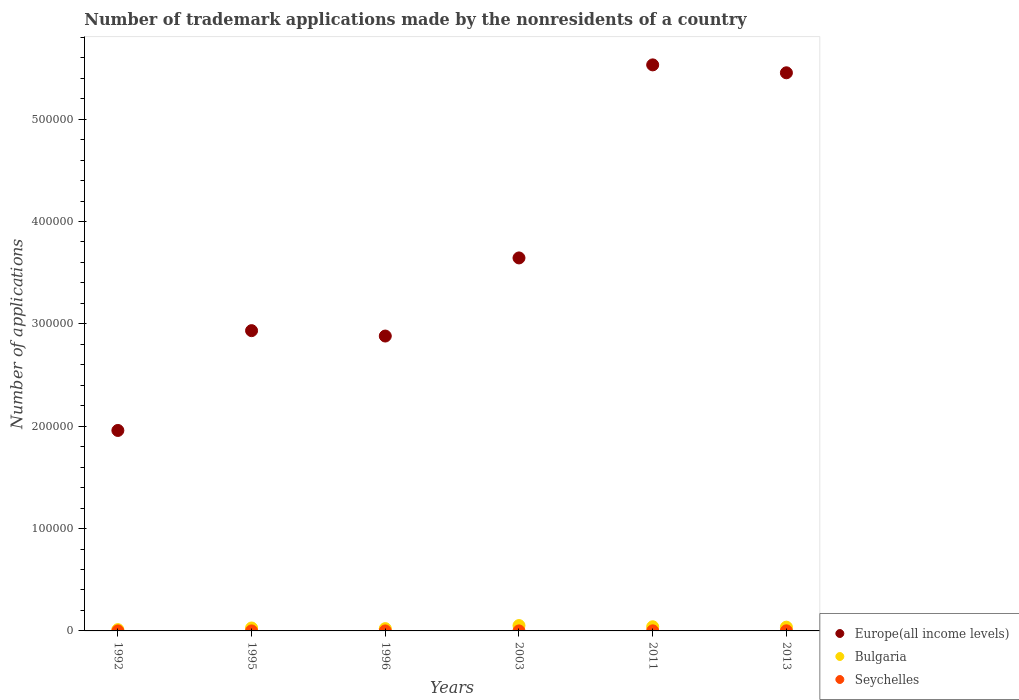How many different coloured dotlines are there?
Your answer should be compact. 3. What is the number of trademark applications made by the nonresidents in Bulgaria in 2011?
Your response must be concise. 4058. Across all years, what is the maximum number of trademark applications made by the nonresidents in Bulgaria?
Your response must be concise. 5225. Across all years, what is the minimum number of trademark applications made by the nonresidents in Europe(all income levels)?
Your response must be concise. 1.96e+05. In which year was the number of trademark applications made by the nonresidents in Europe(all income levels) minimum?
Provide a succinct answer. 1992. What is the total number of trademark applications made by the nonresidents in Seychelles in the graph?
Give a very brief answer. 244. What is the difference between the number of trademark applications made by the nonresidents in Bulgaria in 2011 and that in 2013?
Your answer should be very brief. 378. What is the difference between the number of trademark applications made by the nonresidents in Bulgaria in 2013 and the number of trademark applications made by the nonresidents in Seychelles in 1995?
Your response must be concise. 3664. What is the average number of trademark applications made by the nonresidents in Seychelles per year?
Offer a very short reply. 40.67. In the year 1995, what is the difference between the number of trademark applications made by the nonresidents in Bulgaria and number of trademark applications made by the nonresidents in Seychelles?
Your answer should be compact. 2843. In how many years, is the number of trademark applications made by the nonresidents in Europe(all income levels) greater than 60000?
Make the answer very short. 6. What is the ratio of the number of trademark applications made by the nonresidents in Bulgaria in 1992 to that in 2013?
Keep it short and to the point. 0.34. What is the difference between the highest and the lowest number of trademark applications made by the nonresidents in Bulgaria?
Offer a very short reply. 3973. Is it the case that in every year, the sum of the number of trademark applications made by the nonresidents in Seychelles and number of trademark applications made by the nonresidents in Europe(all income levels)  is greater than the number of trademark applications made by the nonresidents in Bulgaria?
Offer a terse response. Yes. Does the number of trademark applications made by the nonresidents in Bulgaria monotonically increase over the years?
Keep it short and to the point. No. Is the number of trademark applications made by the nonresidents in Seychelles strictly greater than the number of trademark applications made by the nonresidents in Bulgaria over the years?
Give a very brief answer. No. Is the number of trademark applications made by the nonresidents in Bulgaria strictly less than the number of trademark applications made by the nonresidents in Seychelles over the years?
Your answer should be very brief. No. How many dotlines are there?
Give a very brief answer. 3. Does the graph contain grids?
Provide a short and direct response. No. Where does the legend appear in the graph?
Your answer should be compact. Bottom right. What is the title of the graph?
Your answer should be very brief. Number of trademark applications made by the nonresidents of a country. Does "Least developed countries" appear as one of the legend labels in the graph?
Your response must be concise. No. What is the label or title of the X-axis?
Make the answer very short. Years. What is the label or title of the Y-axis?
Give a very brief answer. Number of applications. What is the Number of applications of Europe(all income levels) in 1992?
Provide a short and direct response. 1.96e+05. What is the Number of applications in Bulgaria in 1992?
Offer a very short reply. 1252. What is the Number of applications of Seychelles in 1992?
Give a very brief answer. 3. What is the Number of applications in Europe(all income levels) in 1995?
Your answer should be compact. 2.93e+05. What is the Number of applications in Bulgaria in 1995?
Your answer should be very brief. 2859. What is the Number of applications in Seychelles in 1995?
Make the answer very short. 16. What is the Number of applications in Europe(all income levels) in 1996?
Your response must be concise. 2.88e+05. What is the Number of applications in Bulgaria in 1996?
Your response must be concise. 2243. What is the Number of applications of Seychelles in 1996?
Your answer should be compact. 12. What is the Number of applications of Europe(all income levels) in 2003?
Offer a very short reply. 3.64e+05. What is the Number of applications of Bulgaria in 2003?
Offer a terse response. 5225. What is the Number of applications in Europe(all income levels) in 2011?
Offer a very short reply. 5.53e+05. What is the Number of applications of Bulgaria in 2011?
Provide a succinct answer. 4058. What is the Number of applications of Seychelles in 2011?
Provide a short and direct response. 91. What is the Number of applications in Europe(all income levels) in 2013?
Give a very brief answer. 5.45e+05. What is the Number of applications of Bulgaria in 2013?
Provide a succinct answer. 3680. What is the Number of applications in Seychelles in 2013?
Ensure brevity in your answer.  106. Across all years, what is the maximum Number of applications of Europe(all income levels)?
Offer a very short reply. 5.53e+05. Across all years, what is the maximum Number of applications in Bulgaria?
Your answer should be compact. 5225. Across all years, what is the maximum Number of applications of Seychelles?
Give a very brief answer. 106. Across all years, what is the minimum Number of applications in Europe(all income levels)?
Give a very brief answer. 1.96e+05. Across all years, what is the minimum Number of applications in Bulgaria?
Keep it short and to the point. 1252. What is the total Number of applications in Europe(all income levels) in the graph?
Offer a very short reply. 2.24e+06. What is the total Number of applications of Bulgaria in the graph?
Provide a succinct answer. 1.93e+04. What is the total Number of applications of Seychelles in the graph?
Provide a succinct answer. 244. What is the difference between the Number of applications in Europe(all income levels) in 1992 and that in 1995?
Provide a short and direct response. -9.75e+04. What is the difference between the Number of applications of Bulgaria in 1992 and that in 1995?
Your answer should be compact. -1607. What is the difference between the Number of applications of Seychelles in 1992 and that in 1995?
Provide a succinct answer. -13. What is the difference between the Number of applications of Europe(all income levels) in 1992 and that in 1996?
Make the answer very short. -9.22e+04. What is the difference between the Number of applications of Bulgaria in 1992 and that in 1996?
Your answer should be very brief. -991. What is the difference between the Number of applications in Europe(all income levels) in 1992 and that in 2003?
Give a very brief answer. -1.69e+05. What is the difference between the Number of applications in Bulgaria in 1992 and that in 2003?
Give a very brief answer. -3973. What is the difference between the Number of applications in Seychelles in 1992 and that in 2003?
Offer a very short reply. -13. What is the difference between the Number of applications of Europe(all income levels) in 1992 and that in 2011?
Give a very brief answer. -3.57e+05. What is the difference between the Number of applications of Bulgaria in 1992 and that in 2011?
Make the answer very short. -2806. What is the difference between the Number of applications in Seychelles in 1992 and that in 2011?
Provide a short and direct response. -88. What is the difference between the Number of applications of Europe(all income levels) in 1992 and that in 2013?
Provide a succinct answer. -3.49e+05. What is the difference between the Number of applications in Bulgaria in 1992 and that in 2013?
Provide a succinct answer. -2428. What is the difference between the Number of applications in Seychelles in 1992 and that in 2013?
Make the answer very short. -103. What is the difference between the Number of applications in Europe(all income levels) in 1995 and that in 1996?
Make the answer very short. 5266. What is the difference between the Number of applications of Bulgaria in 1995 and that in 1996?
Your response must be concise. 616. What is the difference between the Number of applications of Europe(all income levels) in 1995 and that in 2003?
Give a very brief answer. -7.10e+04. What is the difference between the Number of applications in Bulgaria in 1995 and that in 2003?
Ensure brevity in your answer.  -2366. What is the difference between the Number of applications in Seychelles in 1995 and that in 2003?
Give a very brief answer. 0. What is the difference between the Number of applications in Europe(all income levels) in 1995 and that in 2011?
Provide a succinct answer. -2.60e+05. What is the difference between the Number of applications of Bulgaria in 1995 and that in 2011?
Give a very brief answer. -1199. What is the difference between the Number of applications of Seychelles in 1995 and that in 2011?
Give a very brief answer. -75. What is the difference between the Number of applications in Europe(all income levels) in 1995 and that in 2013?
Give a very brief answer. -2.52e+05. What is the difference between the Number of applications in Bulgaria in 1995 and that in 2013?
Give a very brief answer. -821. What is the difference between the Number of applications in Seychelles in 1995 and that in 2013?
Your answer should be very brief. -90. What is the difference between the Number of applications of Europe(all income levels) in 1996 and that in 2003?
Ensure brevity in your answer.  -7.63e+04. What is the difference between the Number of applications of Bulgaria in 1996 and that in 2003?
Offer a terse response. -2982. What is the difference between the Number of applications in Europe(all income levels) in 1996 and that in 2011?
Your response must be concise. -2.65e+05. What is the difference between the Number of applications of Bulgaria in 1996 and that in 2011?
Offer a very short reply. -1815. What is the difference between the Number of applications in Seychelles in 1996 and that in 2011?
Your answer should be compact. -79. What is the difference between the Number of applications of Europe(all income levels) in 1996 and that in 2013?
Ensure brevity in your answer.  -2.57e+05. What is the difference between the Number of applications in Bulgaria in 1996 and that in 2013?
Keep it short and to the point. -1437. What is the difference between the Number of applications of Seychelles in 1996 and that in 2013?
Keep it short and to the point. -94. What is the difference between the Number of applications in Europe(all income levels) in 2003 and that in 2011?
Give a very brief answer. -1.89e+05. What is the difference between the Number of applications in Bulgaria in 2003 and that in 2011?
Offer a terse response. 1167. What is the difference between the Number of applications of Seychelles in 2003 and that in 2011?
Ensure brevity in your answer.  -75. What is the difference between the Number of applications in Europe(all income levels) in 2003 and that in 2013?
Your answer should be compact. -1.81e+05. What is the difference between the Number of applications in Bulgaria in 2003 and that in 2013?
Give a very brief answer. 1545. What is the difference between the Number of applications in Seychelles in 2003 and that in 2013?
Your answer should be compact. -90. What is the difference between the Number of applications in Europe(all income levels) in 2011 and that in 2013?
Provide a short and direct response. 7737. What is the difference between the Number of applications of Bulgaria in 2011 and that in 2013?
Offer a terse response. 378. What is the difference between the Number of applications of Seychelles in 2011 and that in 2013?
Give a very brief answer. -15. What is the difference between the Number of applications of Europe(all income levels) in 1992 and the Number of applications of Bulgaria in 1995?
Your answer should be compact. 1.93e+05. What is the difference between the Number of applications in Europe(all income levels) in 1992 and the Number of applications in Seychelles in 1995?
Offer a very short reply. 1.96e+05. What is the difference between the Number of applications in Bulgaria in 1992 and the Number of applications in Seychelles in 1995?
Offer a very short reply. 1236. What is the difference between the Number of applications of Europe(all income levels) in 1992 and the Number of applications of Bulgaria in 1996?
Your response must be concise. 1.94e+05. What is the difference between the Number of applications of Europe(all income levels) in 1992 and the Number of applications of Seychelles in 1996?
Provide a short and direct response. 1.96e+05. What is the difference between the Number of applications of Bulgaria in 1992 and the Number of applications of Seychelles in 1996?
Provide a succinct answer. 1240. What is the difference between the Number of applications in Europe(all income levels) in 1992 and the Number of applications in Bulgaria in 2003?
Your answer should be very brief. 1.91e+05. What is the difference between the Number of applications of Europe(all income levels) in 1992 and the Number of applications of Seychelles in 2003?
Your response must be concise. 1.96e+05. What is the difference between the Number of applications of Bulgaria in 1992 and the Number of applications of Seychelles in 2003?
Offer a terse response. 1236. What is the difference between the Number of applications in Europe(all income levels) in 1992 and the Number of applications in Bulgaria in 2011?
Offer a terse response. 1.92e+05. What is the difference between the Number of applications of Europe(all income levels) in 1992 and the Number of applications of Seychelles in 2011?
Give a very brief answer. 1.96e+05. What is the difference between the Number of applications of Bulgaria in 1992 and the Number of applications of Seychelles in 2011?
Your answer should be compact. 1161. What is the difference between the Number of applications of Europe(all income levels) in 1992 and the Number of applications of Bulgaria in 2013?
Offer a terse response. 1.92e+05. What is the difference between the Number of applications in Europe(all income levels) in 1992 and the Number of applications in Seychelles in 2013?
Keep it short and to the point. 1.96e+05. What is the difference between the Number of applications of Bulgaria in 1992 and the Number of applications of Seychelles in 2013?
Offer a very short reply. 1146. What is the difference between the Number of applications of Europe(all income levels) in 1995 and the Number of applications of Bulgaria in 1996?
Provide a succinct answer. 2.91e+05. What is the difference between the Number of applications of Europe(all income levels) in 1995 and the Number of applications of Seychelles in 1996?
Your answer should be very brief. 2.93e+05. What is the difference between the Number of applications in Bulgaria in 1995 and the Number of applications in Seychelles in 1996?
Provide a succinct answer. 2847. What is the difference between the Number of applications of Europe(all income levels) in 1995 and the Number of applications of Bulgaria in 2003?
Make the answer very short. 2.88e+05. What is the difference between the Number of applications of Europe(all income levels) in 1995 and the Number of applications of Seychelles in 2003?
Ensure brevity in your answer.  2.93e+05. What is the difference between the Number of applications of Bulgaria in 1995 and the Number of applications of Seychelles in 2003?
Your answer should be compact. 2843. What is the difference between the Number of applications of Europe(all income levels) in 1995 and the Number of applications of Bulgaria in 2011?
Your answer should be compact. 2.89e+05. What is the difference between the Number of applications in Europe(all income levels) in 1995 and the Number of applications in Seychelles in 2011?
Provide a short and direct response. 2.93e+05. What is the difference between the Number of applications in Bulgaria in 1995 and the Number of applications in Seychelles in 2011?
Provide a short and direct response. 2768. What is the difference between the Number of applications of Europe(all income levels) in 1995 and the Number of applications of Bulgaria in 2013?
Your answer should be very brief. 2.90e+05. What is the difference between the Number of applications in Europe(all income levels) in 1995 and the Number of applications in Seychelles in 2013?
Keep it short and to the point. 2.93e+05. What is the difference between the Number of applications of Bulgaria in 1995 and the Number of applications of Seychelles in 2013?
Ensure brevity in your answer.  2753. What is the difference between the Number of applications of Europe(all income levels) in 1996 and the Number of applications of Bulgaria in 2003?
Offer a very short reply. 2.83e+05. What is the difference between the Number of applications in Europe(all income levels) in 1996 and the Number of applications in Seychelles in 2003?
Your response must be concise. 2.88e+05. What is the difference between the Number of applications of Bulgaria in 1996 and the Number of applications of Seychelles in 2003?
Offer a terse response. 2227. What is the difference between the Number of applications of Europe(all income levels) in 1996 and the Number of applications of Bulgaria in 2011?
Make the answer very short. 2.84e+05. What is the difference between the Number of applications of Europe(all income levels) in 1996 and the Number of applications of Seychelles in 2011?
Offer a terse response. 2.88e+05. What is the difference between the Number of applications in Bulgaria in 1996 and the Number of applications in Seychelles in 2011?
Ensure brevity in your answer.  2152. What is the difference between the Number of applications in Europe(all income levels) in 1996 and the Number of applications in Bulgaria in 2013?
Your answer should be compact. 2.84e+05. What is the difference between the Number of applications of Europe(all income levels) in 1996 and the Number of applications of Seychelles in 2013?
Give a very brief answer. 2.88e+05. What is the difference between the Number of applications in Bulgaria in 1996 and the Number of applications in Seychelles in 2013?
Your answer should be very brief. 2137. What is the difference between the Number of applications of Europe(all income levels) in 2003 and the Number of applications of Bulgaria in 2011?
Your response must be concise. 3.60e+05. What is the difference between the Number of applications of Europe(all income levels) in 2003 and the Number of applications of Seychelles in 2011?
Make the answer very short. 3.64e+05. What is the difference between the Number of applications in Bulgaria in 2003 and the Number of applications in Seychelles in 2011?
Give a very brief answer. 5134. What is the difference between the Number of applications in Europe(all income levels) in 2003 and the Number of applications in Bulgaria in 2013?
Provide a short and direct response. 3.61e+05. What is the difference between the Number of applications in Europe(all income levels) in 2003 and the Number of applications in Seychelles in 2013?
Offer a terse response. 3.64e+05. What is the difference between the Number of applications in Bulgaria in 2003 and the Number of applications in Seychelles in 2013?
Give a very brief answer. 5119. What is the difference between the Number of applications of Europe(all income levels) in 2011 and the Number of applications of Bulgaria in 2013?
Your answer should be very brief. 5.49e+05. What is the difference between the Number of applications of Europe(all income levels) in 2011 and the Number of applications of Seychelles in 2013?
Offer a very short reply. 5.53e+05. What is the difference between the Number of applications of Bulgaria in 2011 and the Number of applications of Seychelles in 2013?
Provide a succinct answer. 3952. What is the average Number of applications of Europe(all income levels) per year?
Provide a short and direct response. 3.73e+05. What is the average Number of applications in Bulgaria per year?
Your answer should be very brief. 3219.5. What is the average Number of applications in Seychelles per year?
Your answer should be very brief. 40.67. In the year 1992, what is the difference between the Number of applications in Europe(all income levels) and Number of applications in Bulgaria?
Ensure brevity in your answer.  1.95e+05. In the year 1992, what is the difference between the Number of applications in Europe(all income levels) and Number of applications in Seychelles?
Keep it short and to the point. 1.96e+05. In the year 1992, what is the difference between the Number of applications in Bulgaria and Number of applications in Seychelles?
Your answer should be compact. 1249. In the year 1995, what is the difference between the Number of applications in Europe(all income levels) and Number of applications in Bulgaria?
Your answer should be very brief. 2.90e+05. In the year 1995, what is the difference between the Number of applications of Europe(all income levels) and Number of applications of Seychelles?
Provide a succinct answer. 2.93e+05. In the year 1995, what is the difference between the Number of applications in Bulgaria and Number of applications in Seychelles?
Your response must be concise. 2843. In the year 1996, what is the difference between the Number of applications in Europe(all income levels) and Number of applications in Bulgaria?
Your response must be concise. 2.86e+05. In the year 1996, what is the difference between the Number of applications of Europe(all income levels) and Number of applications of Seychelles?
Your response must be concise. 2.88e+05. In the year 1996, what is the difference between the Number of applications in Bulgaria and Number of applications in Seychelles?
Offer a very short reply. 2231. In the year 2003, what is the difference between the Number of applications in Europe(all income levels) and Number of applications in Bulgaria?
Ensure brevity in your answer.  3.59e+05. In the year 2003, what is the difference between the Number of applications of Europe(all income levels) and Number of applications of Seychelles?
Ensure brevity in your answer.  3.64e+05. In the year 2003, what is the difference between the Number of applications in Bulgaria and Number of applications in Seychelles?
Your answer should be compact. 5209. In the year 2011, what is the difference between the Number of applications in Europe(all income levels) and Number of applications in Bulgaria?
Keep it short and to the point. 5.49e+05. In the year 2011, what is the difference between the Number of applications of Europe(all income levels) and Number of applications of Seychelles?
Provide a succinct answer. 5.53e+05. In the year 2011, what is the difference between the Number of applications of Bulgaria and Number of applications of Seychelles?
Provide a short and direct response. 3967. In the year 2013, what is the difference between the Number of applications of Europe(all income levels) and Number of applications of Bulgaria?
Provide a short and direct response. 5.42e+05. In the year 2013, what is the difference between the Number of applications in Europe(all income levels) and Number of applications in Seychelles?
Offer a terse response. 5.45e+05. In the year 2013, what is the difference between the Number of applications of Bulgaria and Number of applications of Seychelles?
Offer a terse response. 3574. What is the ratio of the Number of applications of Europe(all income levels) in 1992 to that in 1995?
Offer a terse response. 0.67. What is the ratio of the Number of applications in Bulgaria in 1992 to that in 1995?
Offer a very short reply. 0.44. What is the ratio of the Number of applications of Seychelles in 1992 to that in 1995?
Keep it short and to the point. 0.19. What is the ratio of the Number of applications in Europe(all income levels) in 1992 to that in 1996?
Provide a succinct answer. 0.68. What is the ratio of the Number of applications in Bulgaria in 1992 to that in 1996?
Your answer should be very brief. 0.56. What is the ratio of the Number of applications of Seychelles in 1992 to that in 1996?
Offer a terse response. 0.25. What is the ratio of the Number of applications of Europe(all income levels) in 1992 to that in 2003?
Keep it short and to the point. 0.54. What is the ratio of the Number of applications in Bulgaria in 1992 to that in 2003?
Offer a terse response. 0.24. What is the ratio of the Number of applications in Seychelles in 1992 to that in 2003?
Offer a very short reply. 0.19. What is the ratio of the Number of applications of Europe(all income levels) in 1992 to that in 2011?
Offer a very short reply. 0.35. What is the ratio of the Number of applications of Bulgaria in 1992 to that in 2011?
Your answer should be very brief. 0.31. What is the ratio of the Number of applications of Seychelles in 1992 to that in 2011?
Your response must be concise. 0.03. What is the ratio of the Number of applications in Europe(all income levels) in 1992 to that in 2013?
Keep it short and to the point. 0.36. What is the ratio of the Number of applications in Bulgaria in 1992 to that in 2013?
Keep it short and to the point. 0.34. What is the ratio of the Number of applications in Seychelles in 1992 to that in 2013?
Provide a short and direct response. 0.03. What is the ratio of the Number of applications in Europe(all income levels) in 1995 to that in 1996?
Your answer should be very brief. 1.02. What is the ratio of the Number of applications of Bulgaria in 1995 to that in 1996?
Provide a short and direct response. 1.27. What is the ratio of the Number of applications in Europe(all income levels) in 1995 to that in 2003?
Make the answer very short. 0.81. What is the ratio of the Number of applications in Bulgaria in 1995 to that in 2003?
Make the answer very short. 0.55. What is the ratio of the Number of applications in Seychelles in 1995 to that in 2003?
Provide a short and direct response. 1. What is the ratio of the Number of applications in Europe(all income levels) in 1995 to that in 2011?
Give a very brief answer. 0.53. What is the ratio of the Number of applications in Bulgaria in 1995 to that in 2011?
Your response must be concise. 0.7. What is the ratio of the Number of applications of Seychelles in 1995 to that in 2011?
Your answer should be very brief. 0.18. What is the ratio of the Number of applications in Europe(all income levels) in 1995 to that in 2013?
Your answer should be compact. 0.54. What is the ratio of the Number of applications of Bulgaria in 1995 to that in 2013?
Provide a succinct answer. 0.78. What is the ratio of the Number of applications in Seychelles in 1995 to that in 2013?
Your response must be concise. 0.15. What is the ratio of the Number of applications of Europe(all income levels) in 1996 to that in 2003?
Provide a succinct answer. 0.79. What is the ratio of the Number of applications in Bulgaria in 1996 to that in 2003?
Provide a succinct answer. 0.43. What is the ratio of the Number of applications of Europe(all income levels) in 1996 to that in 2011?
Offer a terse response. 0.52. What is the ratio of the Number of applications of Bulgaria in 1996 to that in 2011?
Offer a very short reply. 0.55. What is the ratio of the Number of applications in Seychelles in 1996 to that in 2011?
Offer a very short reply. 0.13. What is the ratio of the Number of applications of Europe(all income levels) in 1996 to that in 2013?
Offer a very short reply. 0.53. What is the ratio of the Number of applications of Bulgaria in 1996 to that in 2013?
Offer a terse response. 0.61. What is the ratio of the Number of applications in Seychelles in 1996 to that in 2013?
Provide a succinct answer. 0.11. What is the ratio of the Number of applications in Europe(all income levels) in 2003 to that in 2011?
Your answer should be compact. 0.66. What is the ratio of the Number of applications in Bulgaria in 2003 to that in 2011?
Make the answer very short. 1.29. What is the ratio of the Number of applications in Seychelles in 2003 to that in 2011?
Make the answer very short. 0.18. What is the ratio of the Number of applications in Europe(all income levels) in 2003 to that in 2013?
Ensure brevity in your answer.  0.67. What is the ratio of the Number of applications in Bulgaria in 2003 to that in 2013?
Ensure brevity in your answer.  1.42. What is the ratio of the Number of applications in Seychelles in 2003 to that in 2013?
Provide a succinct answer. 0.15. What is the ratio of the Number of applications in Europe(all income levels) in 2011 to that in 2013?
Provide a short and direct response. 1.01. What is the ratio of the Number of applications of Bulgaria in 2011 to that in 2013?
Ensure brevity in your answer.  1.1. What is the ratio of the Number of applications of Seychelles in 2011 to that in 2013?
Make the answer very short. 0.86. What is the difference between the highest and the second highest Number of applications in Europe(all income levels)?
Offer a very short reply. 7737. What is the difference between the highest and the second highest Number of applications in Bulgaria?
Make the answer very short. 1167. What is the difference between the highest and the lowest Number of applications in Europe(all income levels)?
Provide a short and direct response. 3.57e+05. What is the difference between the highest and the lowest Number of applications in Bulgaria?
Give a very brief answer. 3973. What is the difference between the highest and the lowest Number of applications in Seychelles?
Your answer should be compact. 103. 